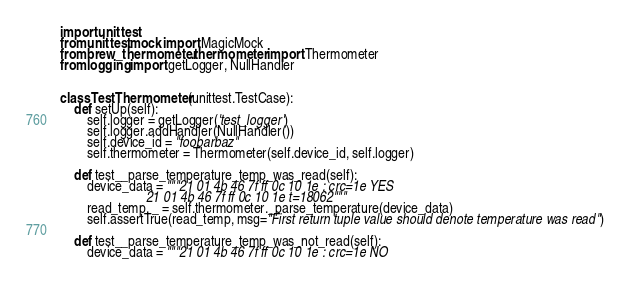<code> <loc_0><loc_0><loc_500><loc_500><_Python_>import unittest
from unittest.mock import MagicMock
from brew_thermometer.thermometer import Thermometer
from logging import getLogger, NullHandler


class TestThermometer(unittest.TestCase):
    def setUp(self):
        self.logger = getLogger('test_logger')
        self.logger.addHandler(NullHandler())
        self.device_id = "foobarbaz"
        self.thermometer = Thermometer(self.device_id, self.logger)

    def test__parse_temperature_temp_was_read(self):
        device_data = """21 01 4b 46 7f ff 0c 10 1e : crc=1e YES
                         21 01 4b 46 7f ff 0c 10 1e t=18062"""
        read_temp, _ = self.thermometer._parse_temperature(device_data)
        self.assertTrue(read_temp, msg="First return tuple value should denote temperature was read")

    def test__parse_temperature_temp_was_not_read(self):
        device_data = """21 01 4b 46 7f ff 0c 10 1e : crc=1e NO</code> 